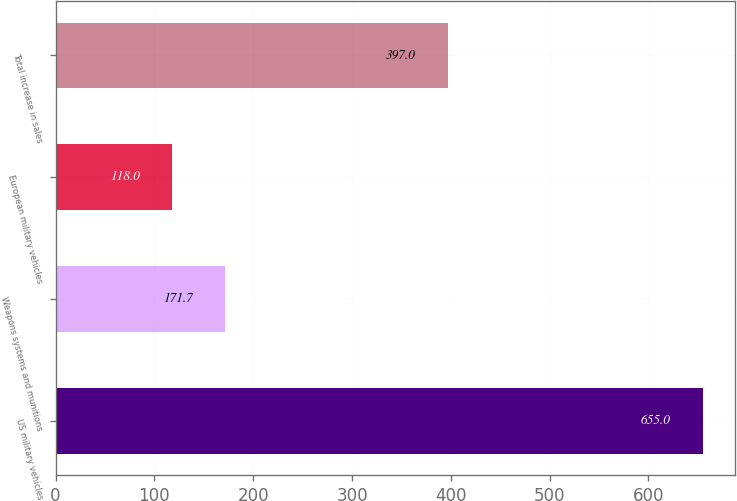Convert chart to OTSL. <chart><loc_0><loc_0><loc_500><loc_500><bar_chart><fcel>US military vehicles<fcel>Weapons systems and munitions<fcel>European military vehicles<fcel>Total increase in sales<nl><fcel>655<fcel>171.7<fcel>118<fcel>397<nl></chart> 